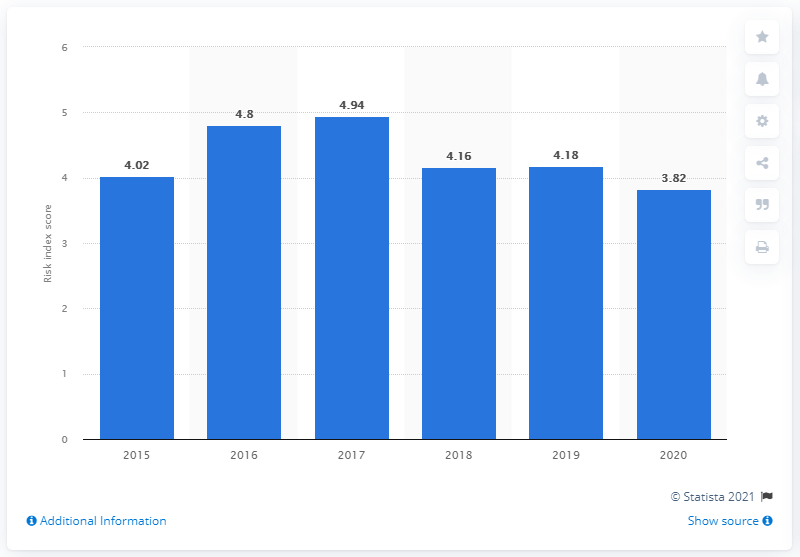Point out several critical features in this image. Chile's index score in 2020 was 3.82. 